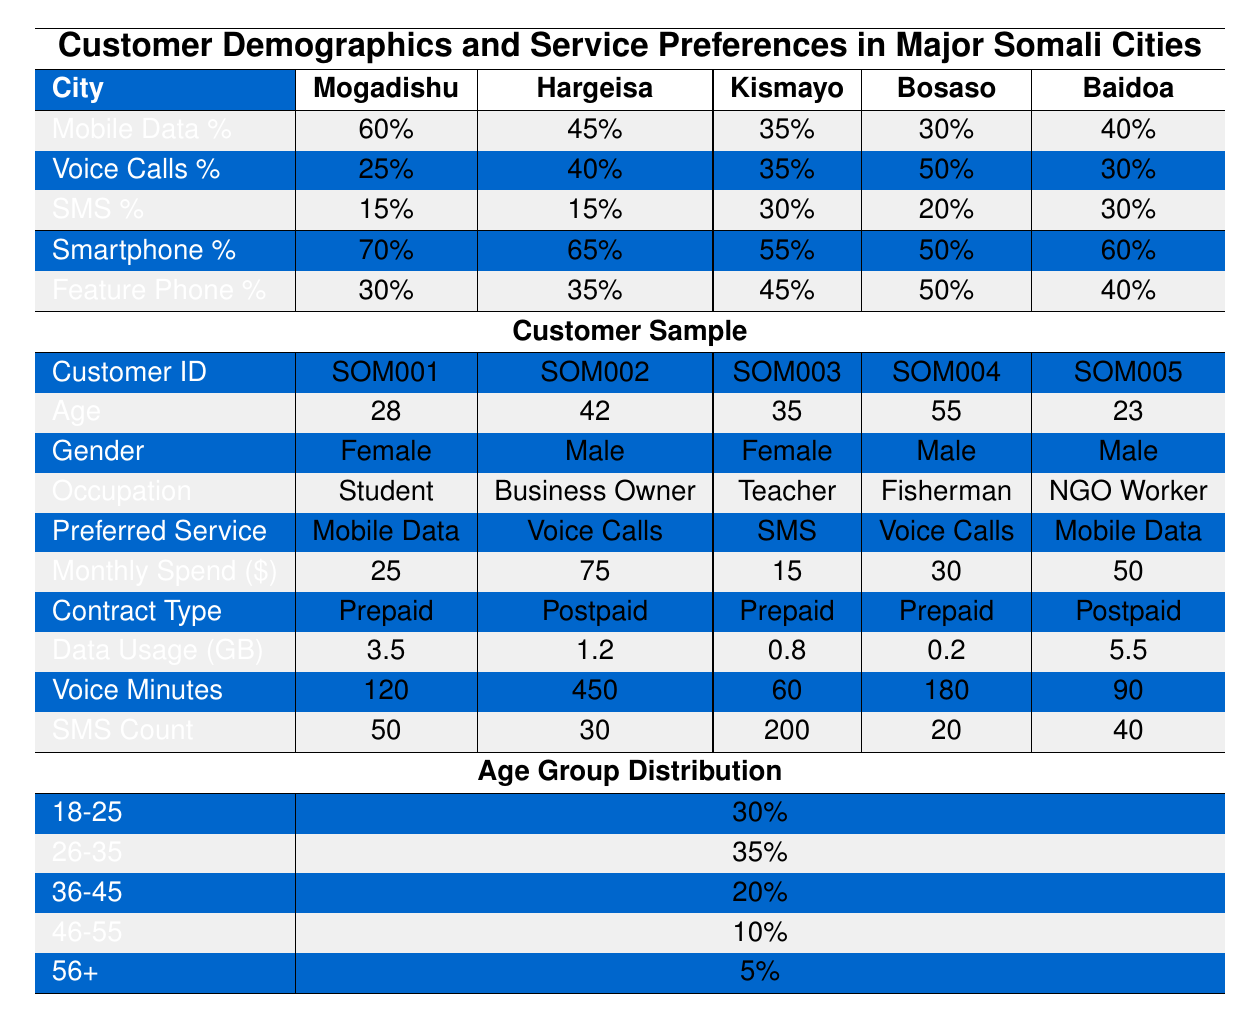What is the preferred service for customers in Baidoa? The table shows that the preferred service for Baidoa is "Mobile Data."
Answer: Mobile Data Which city has the highest percentage of customers preferring mobile data? The table indicates that Mogadishu has the highest percentage of mobile data preference at 60%.
Answer: Mogadishu What percentage of customers in Kismayo prefer SMS as their service? According to the table, 30% of customers in Kismayo prefer SMS.
Answer: 30% How many customers spend more than $50 monthly based on the table? In the customer sample, two customers (SOM002 and SOM005) spend more than $50.
Answer: 2 What is the average monthly spend for customers using smartphones? The smartphone users are SOM001, SOM003, SOM005, and their monthly spends are $25, $15, and $50. Total spend is $25 + $15 + $50 = $90. There are 3 customers, so the average is $90 / 3 = $30.
Answer: $30 Is there a customer in Bosaso who prefers voice calls? The table confirms that customer SOM004 from Bosaso prefers voice calls.
Answer: Yes Which age group constitutes the largest percentage of customers? The age group 26-35 has the highest percentage at 35%, making it the largest age group.
Answer: 26-35 What is the total percentage of voice call preference for customers in Hargeisa and Bosaso combined? Hargeisa has 40% for voice calls, and Bosaso has 50%. Therefore, the total is 40% + 50% = 90%.
Answer: 90% How does the percentage of smartphone users compare between Baidoa and Kismayo? The smartphone percentage in Baidoa is 60%, while in Kismayo, it is 55%. Baidoa has a higher smartphone usage by 5%.
Answer: 5% higher In which city is there a higher proportion of feature phone users: Bosaso or Hargeisa? The table shows Bosaso has 50% feature phone users, while Hargeisa has 35%. Therefore, Bosaso has a higher proportion of feature phone users.
Answer: Bosaso 